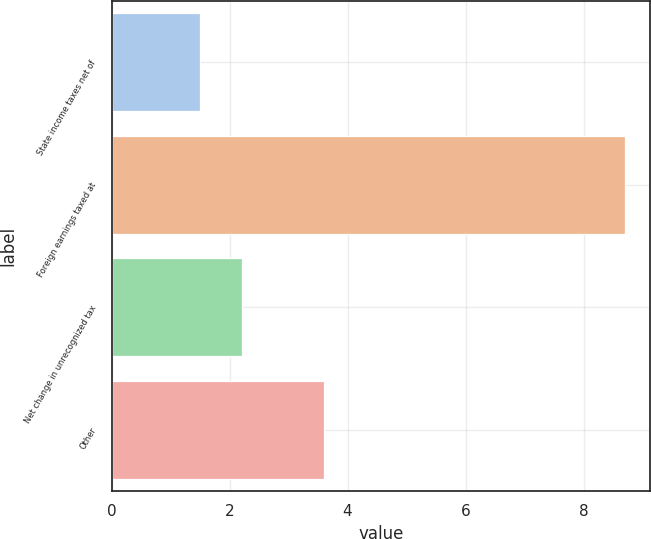Convert chart. <chart><loc_0><loc_0><loc_500><loc_500><bar_chart><fcel>State income taxes net of<fcel>Foreign earnings taxed at<fcel>Net change in unrecognized tax<fcel>Other<nl><fcel>1.5<fcel>8.7<fcel>2.22<fcel>3.6<nl></chart> 